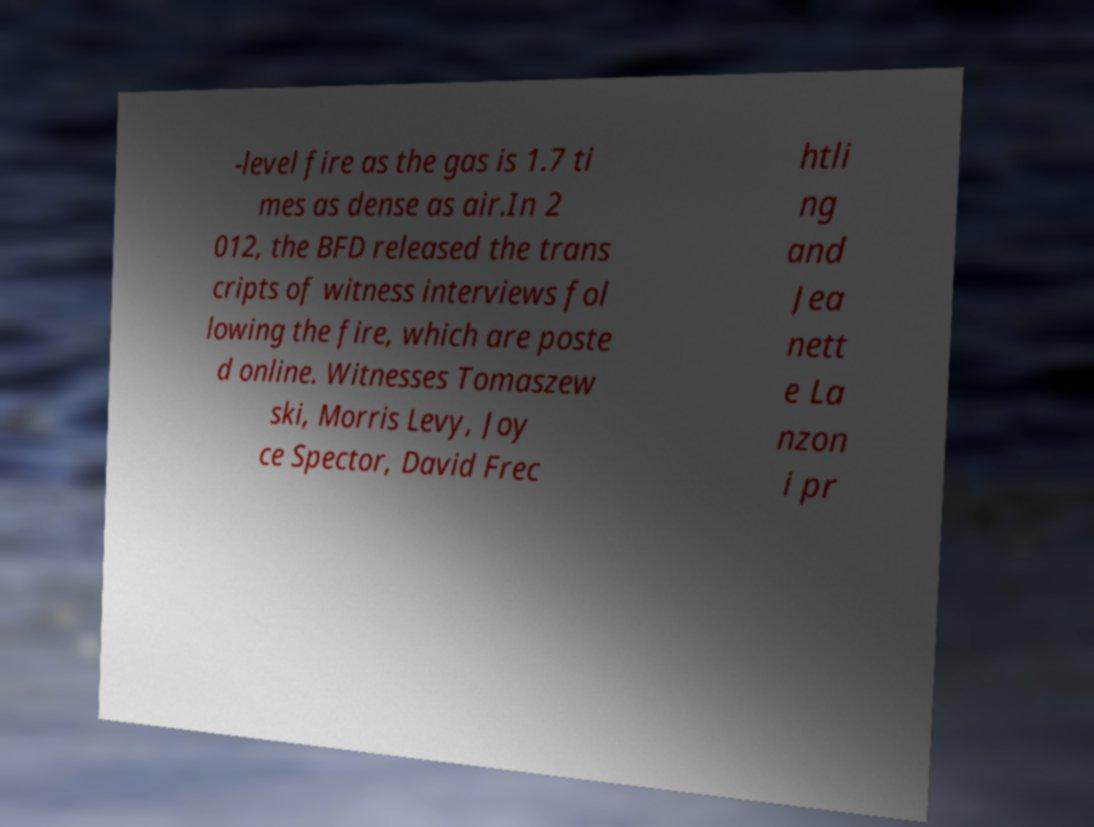I need the written content from this picture converted into text. Can you do that? -level fire as the gas is 1.7 ti mes as dense as air.In 2 012, the BFD released the trans cripts of witness interviews fol lowing the fire, which are poste d online. Witnesses Tomaszew ski, Morris Levy, Joy ce Spector, David Frec htli ng and Jea nett e La nzon i pr 